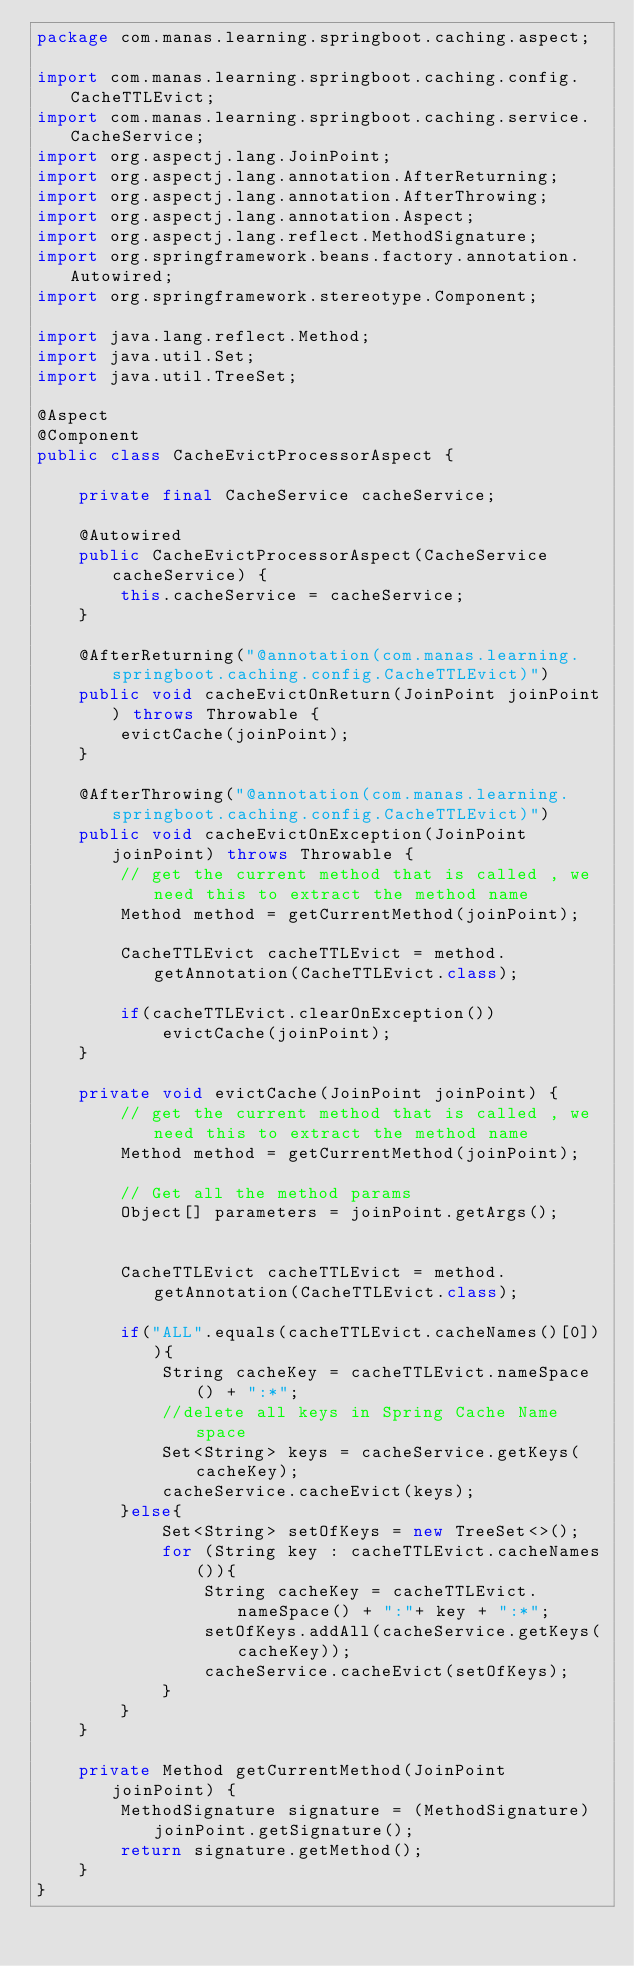Convert code to text. <code><loc_0><loc_0><loc_500><loc_500><_Java_>package com.manas.learning.springboot.caching.aspect;

import com.manas.learning.springboot.caching.config.CacheTTLEvict;
import com.manas.learning.springboot.caching.service.CacheService;
import org.aspectj.lang.JoinPoint;
import org.aspectj.lang.annotation.AfterReturning;
import org.aspectj.lang.annotation.AfterThrowing;
import org.aspectj.lang.annotation.Aspect;
import org.aspectj.lang.reflect.MethodSignature;
import org.springframework.beans.factory.annotation.Autowired;
import org.springframework.stereotype.Component;

import java.lang.reflect.Method;
import java.util.Set;
import java.util.TreeSet;

@Aspect
@Component
public class CacheEvictProcessorAspect {

    private final CacheService cacheService;

    @Autowired
    public CacheEvictProcessorAspect(CacheService cacheService) {
        this.cacheService = cacheService;
    }

    @AfterReturning("@annotation(com.manas.learning.springboot.caching.config.CacheTTLEvict)")
    public void cacheEvictOnReturn(JoinPoint joinPoint) throws Throwable {
        evictCache(joinPoint);
    }

    @AfterThrowing("@annotation(com.manas.learning.springboot.caching.config.CacheTTLEvict)")
    public void cacheEvictOnException(JoinPoint joinPoint) throws Throwable {
        // get the current method that is called , we need this to extract the method name
        Method method = getCurrentMethod(joinPoint);

        CacheTTLEvict cacheTTLEvict = method.getAnnotation(CacheTTLEvict.class);

        if(cacheTTLEvict.clearOnException())
            evictCache(joinPoint);
    }

    private void evictCache(JoinPoint joinPoint) {
        // get the current method that is called , we need this to extract the method name
        Method method = getCurrentMethod(joinPoint);

        // Get all the method params
        Object[] parameters = joinPoint.getArgs();


        CacheTTLEvict cacheTTLEvict = method.getAnnotation(CacheTTLEvict.class);

        if("ALL".equals(cacheTTLEvict.cacheNames()[0])){
            String cacheKey = cacheTTLEvict.nameSpace() + ":*";
            //delete all keys in Spring Cache Name space
            Set<String> keys = cacheService.getKeys(cacheKey);
            cacheService.cacheEvict(keys);
        }else{
            Set<String> setOfKeys = new TreeSet<>();
            for (String key : cacheTTLEvict.cacheNames()){
                String cacheKey = cacheTTLEvict.nameSpace() + ":"+ key + ":*";
                setOfKeys.addAll(cacheService.getKeys(cacheKey));
                cacheService.cacheEvict(setOfKeys);
            }
        }
    }

    private Method getCurrentMethod(JoinPoint joinPoint) {
        MethodSignature signature = (MethodSignature) joinPoint.getSignature();
        return signature.getMethod();
    }
}
</code> 